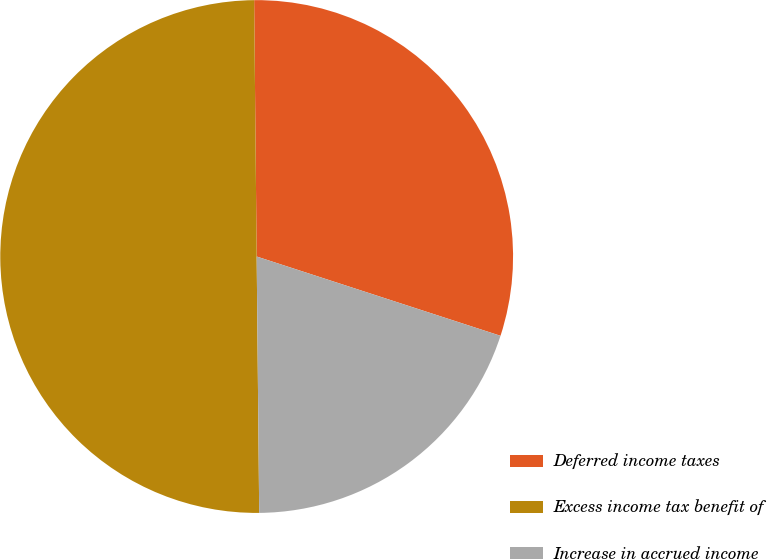Convert chart to OTSL. <chart><loc_0><loc_0><loc_500><loc_500><pie_chart><fcel>Deferred income taxes<fcel>Excess income tax benefit of<fcel>Increase in accrued income<nl><fcel>30.16%<fcel>50.0%<fcel>19.84%<nl></chart> 